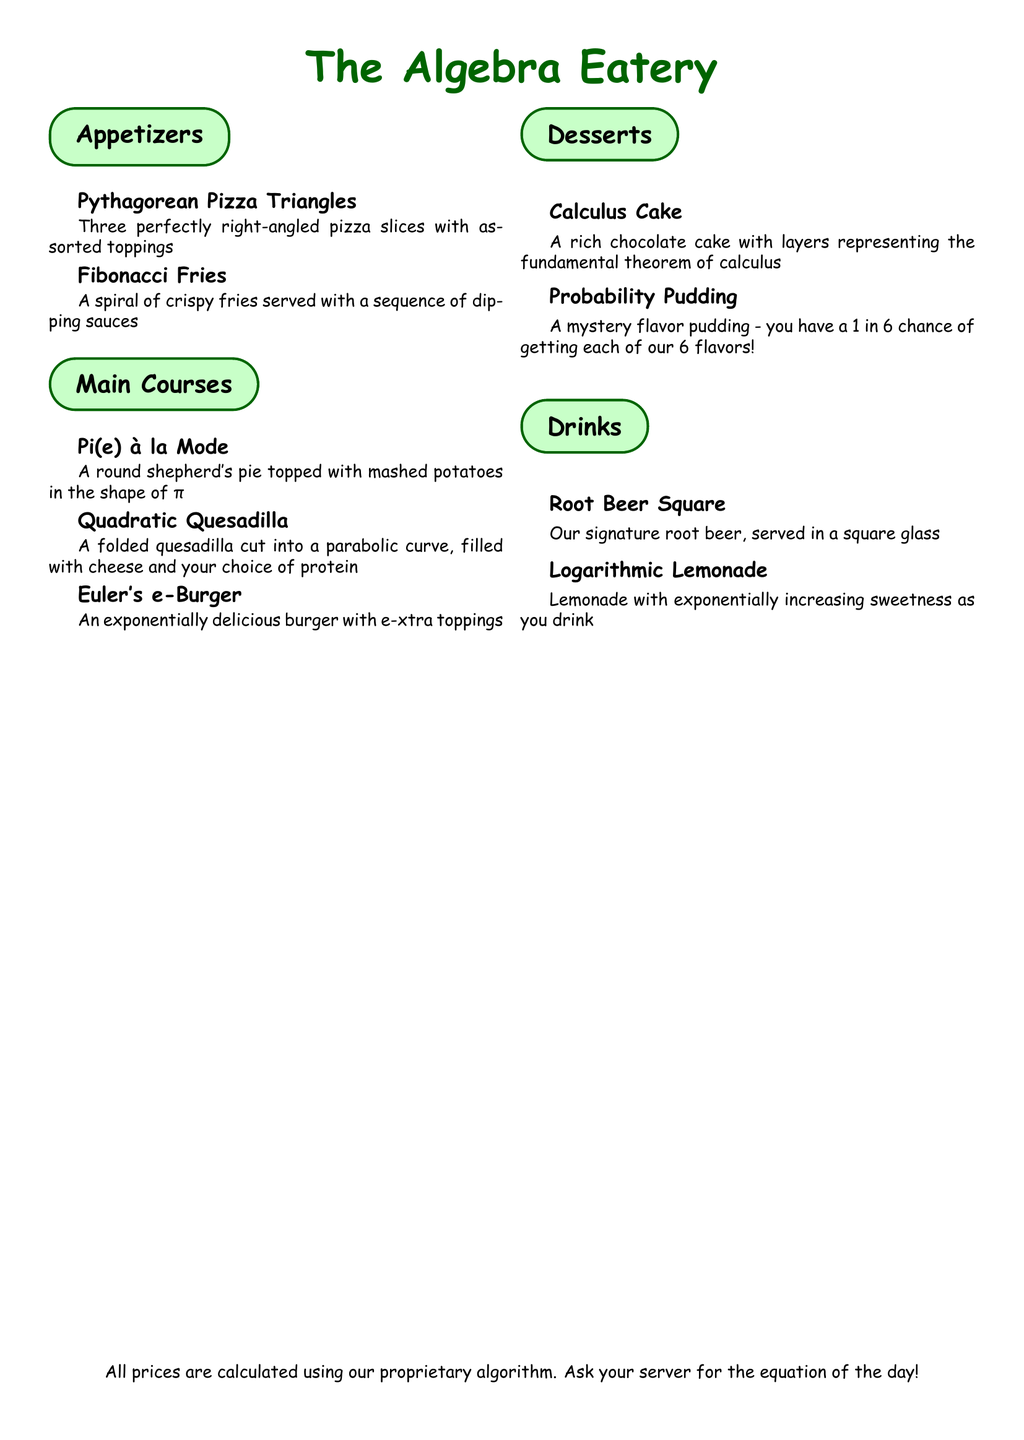What is the name of the restaurant? The name of the restaurant is prominently displayed at the top of the menu.
Answer: The Algebra Eatery What dish is made with a shepherd's pie? The menu lists a specific dish that is a round shepherd's pie, shaped in a particular way.
Answer: Pi(e) à la Mode How many flavors does the Probability Pudding offer? The Probability Pudding has a stated chance of getting one of six flavors, providing the total count of flavors available.
Answer: 6 What is the shape of the Quadratic Quesadilla? The description of this dish includes a reference to a geometric curve indicating its shape.
Answer: Parabolic curve What type of drink is served in a square glass? The drink section mentions a unique drink served specifically in a square glass.
Answer: Root Beer Square How are the fries presented? The fries are described in a way that highlights their unique presentation style.
Answer: A spiral What is a topping option on the Euler's e-Burger? The burger is noted for having extra toppings, and while it doesn't specify, it implies variety.
Answer: e-xtra toppings What cake is based on calculus? The dessert section specifies a cake that relates to the subject of calculus in its name.
Answer: Calculus Cake 